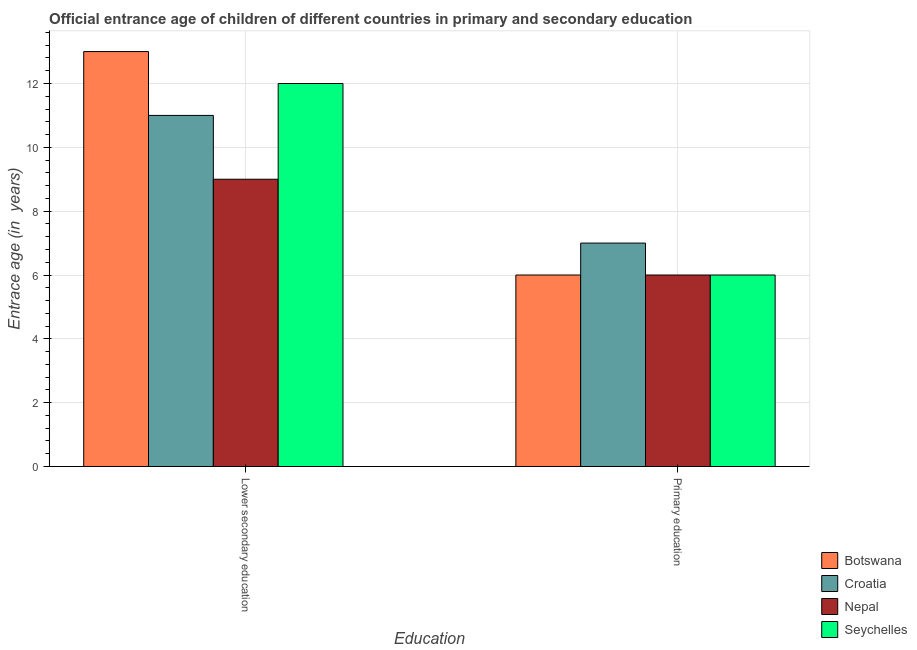How many different coloured bars are there?
Your response must be concise. 4. How many groups of bars are there?
Make the answer very short. 2. Are the number of bars per tick equal to the number of legend labels?
Offer a very short reply. Yes. How many bars are there on the 2nd tick from the left?
Your answer should be very brief. 4. How many bars are there on the 1st tick from the right?
Ensure brevity in your answer.  4. What is the label of the 1st group of bars from the left?
Give a very brief answer. Lower secondary education. What is the entrance age of children in lower secondary education in Botswana?
Your answer should be compact. 13. Across all countries, what is the maximum entrance age of children in lower secondary education?
Offer a terse response. 13. Across all countries, what is the minimum entrance age of children in lower secondary education?
Make the answer very short. 9. In which country was the entrance age of children in lower secondary education maximum?
Give a very brief answer. Botswana. In which country was the entrance age of chiildren in primary education minimum?
Provide a short and direct response. Botswana. What is the total entrance age of chiildren in primary education in the graph?
Your answer should be very brief. 25. What is the difference between the entrance age of children in lower secondary education in Nepal and that in Croatia?
Offer a terse response. -2. What is the difference between the entrance age of chiildren in primary education in Croatia and the entrance age of children in lower secondary education in Botswana?
Offer a terse response. -6. What is the average entrance age of chiildren in primary education per country?
Ensure brevity in your answer.  6.25. What is the difference between the entrance age of children in lower secondary education and entrance age of chiildren in primary education in Nepal?
Make the answer very short. 3. In how many countries, is the entrance age of chiildren in primary education greater than 7.2 years?
Offer a very short reply. 0. What is the ratio of the entrance age of chiildren in primary education in Botswana to that in Seychelles?
Ensure brevity in your answer.  1. In how many countries, is the entrance age of children in lower secondary education greater than the average entrance age of children in lower secondary education taken over all countries?
Your answer should be compact. 2. What does the 4th bar from the left in Primary education represents?
Offer a very short reply. Seychelles. What does the 1st bar from the right in Lower secondary education represents?
Provide a short and direct response. Seychelles. Does the graph contain any zero values?
Give a very brief answer. No. Does the graph contain grids?
Ensure brevity in your answer.  Yes. Where does the legend appear in the graph?
Your response must be concise. Bottom right. What is the title of the graph?
Keep it short and to the point. Official entrance age of children of different countries in primary and secondary education. What is the label or title of the X-axis?
Provide a short and direct response. Education. What is the label or title of the Y-axis?
Provide a short and direct response. Entrace age (in  years). What is the Entrace age (in  years) of Nepal in Lower secondary education?
Give a very brief answer. 9. What is the Entrace age (in  years) in Seychelles in Lower secondary education?
Offer a terse response. 12. What is the Entrace age (in  years) of Botswana in Primary education?
Offer a very short reply. 6. What is the Entrace age (in  years) of Croatia in Primary education?
Your answer should be compact. 7. What is the Entrace age (in  years) of Seychelles in Primary education?
Provide a short and direct response. 6. Across all Education, what is the maximum Entrace age (in  years) of Botswana?
Provide a short and direct response. 13. Across all Education, what is the minimum Entrace age (in  years) in Nepal?
Your response must be concise. 6. Across all Education, what is the minimum Entrace age (in  years) of Seychelles?
Provide a short and direct response. 6. What is the total Entrace age (in  years) of Seychelles in the graph?
Your answer should be compact. 18. What is the difference between the Entrace age (in  years) in Botswana in Lower secondary education and that in Primary education?
Ensure brevity in your answer.  7. What is the difference between the Entrace age (in  years) of Croatia in Lower secondary education and that in Primary education?
Your answer should be very brief. 4. What is the difference between the Entrace age (in  years) of Nepal in Lower secondary education and that in Primary education?
Provide a short and direct response. 3. What is the difference between the Entrace age (in  years) in Botswana in Lower secondary education and the Entrace age (in  years) in Croatia in Primary education?
Keep it short and to the point. 6. What is the difference between the Entrace age (in  years) in Botswana in Lower secondary education and the Entrace age (in  years) in Nepal in Primary education?
Keep it short and to the point. 7. What is the difference between the Entrace age (in  years) of Botswana in Lower secondary education and the Entrace age (in  years) of Seychelles in Primary education?
Make the answer very short. 7. What is the average Entrace age (in  years) in Croatia per Education?
Your response must be concise. 9. What is the difference between the Entrace age (in  years) of Botswana and Entrace age (in  years) of Croatia in Lower secondary education?
Your response must be concise. 2. What is the difference between the Entrace age (in  years) of Croatia and Entrace age (in  years) of Nepal in Lower secondary education?
Your response must be concise. 2. What is the difference between the Entrace age (in  years) of Botswana and Entrace age (in  years) of Nepal in Primary education?
Your response must be concise. 0. What is the difference between the Entrace age (in  years) in Botswana and Entrace age (in  years) in Seychelles in Primary education?
Provide a short and direct response. 0. What is the difference between the Entrace age (in  years) in Croatia and Entrace age (in  years) in Seychelles in Primary education?
Provide a succinct answer. 1. What is the ratio of the Entrace age (in  years) in Botswana in Lower secondary education to that in Primary education?
Offer a very short reply. 2.17. What is the ratio of the Entrace age (in  years) of Croatia in Lower secondary education to that in Primary education?
Your answer should be very brief. 1.57. What is the ratio of the Entrace age (in  years) in Nepal in Lower secondary education to that in Primary education?
Your answer should be very brief. 1.5. What is the ratio of the Entrace age (in  years) in Seychelles in Lower secondary education to that in Primary education?
Offer a very short reply. 2. What is the difference between the highest and the second highest Entrace age (in  years) in Nepal?
Keep it short and to the point. 3. What is the difference between the highest and the lowest Entrace age (in  years) in Botswana?
Keep it short and to the point. 7. What is the difference between the highest and the lowest Entrace age (in  years) in Seychelles?
Keep it short and to the point. 6. 